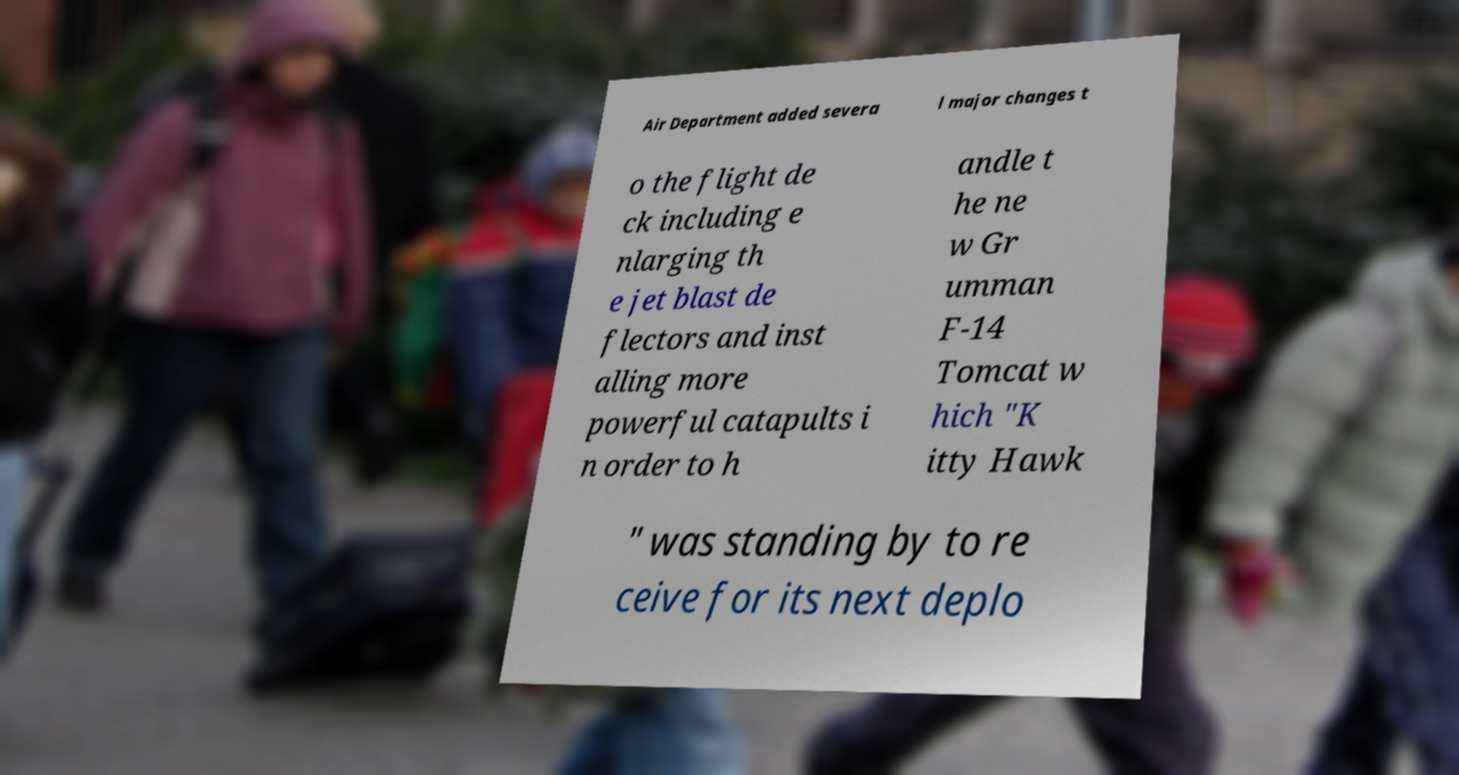Could you extract and type out the text from this image? Air Department added severa l major changes t o the flight de ck including e nlarging th e jet blast de flectors and inst alling more powerful catapults i n order to h andle t he ne w Gr umman F-14 Tomcat w hich "K itty Hawk " was standing by to re ceive for its next deplo 